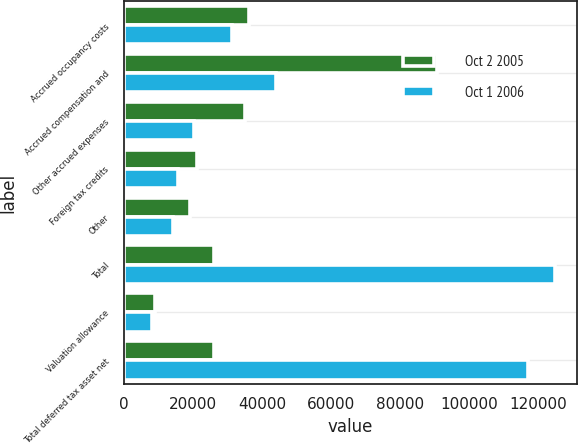<chart> <loc_0><loc_0><loc_500><loc_500><stacked_bar_chart><ecel><fcel>Accrued occupancy costs<fcel>Accrued compensation and<fcel>Other accrued expenses<fcel>Foreign tax credits<fcel>Other<fcel>Total<fcel>Valuation allowance<fcel>Total deferred tax asset net<nl><fcel>Oct 2 2005<fcel>36205<fcel>90815<fcel>34959<fcel>20948<fcel>19095<fcel>26097.5<fcel>8767<fcel>26097.5<nl><fcel>Oct 1 2006<fcel>31247<fcel>43890<fcel>20199<fcel>15708<fcel>13990<fcel>125034<fcel>8078<fcel>116956<nl></chart> 